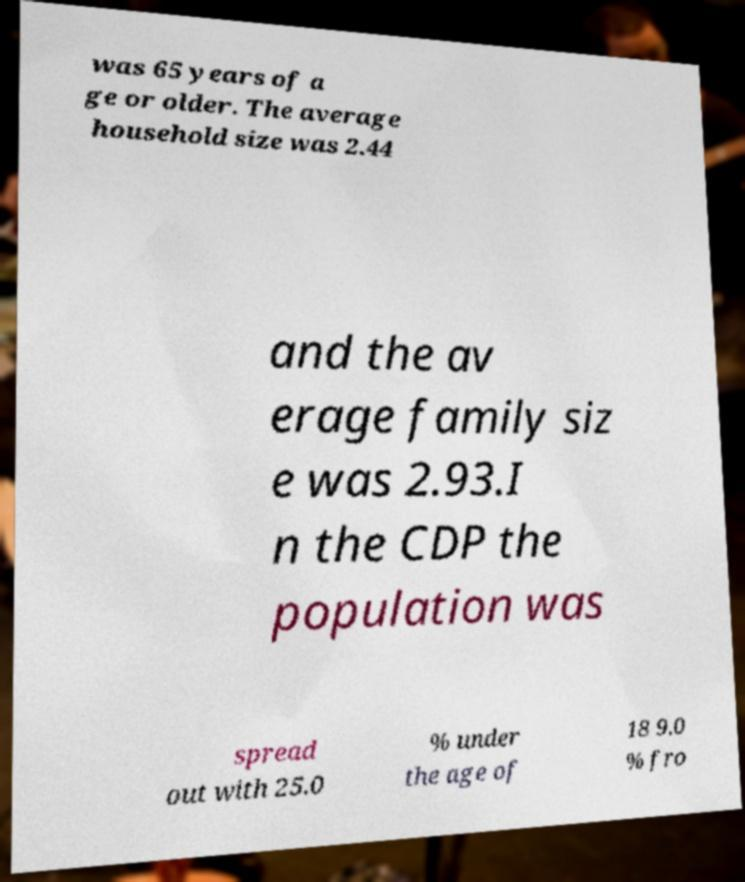Could you extract and type out the text from this image? was 65 years of a ge or older. The average household size was 2.44 and the av erage family siz e was 2.93.I n the CDP the population was spread out with 25.0 % under the age of 18 9.0 % fro 